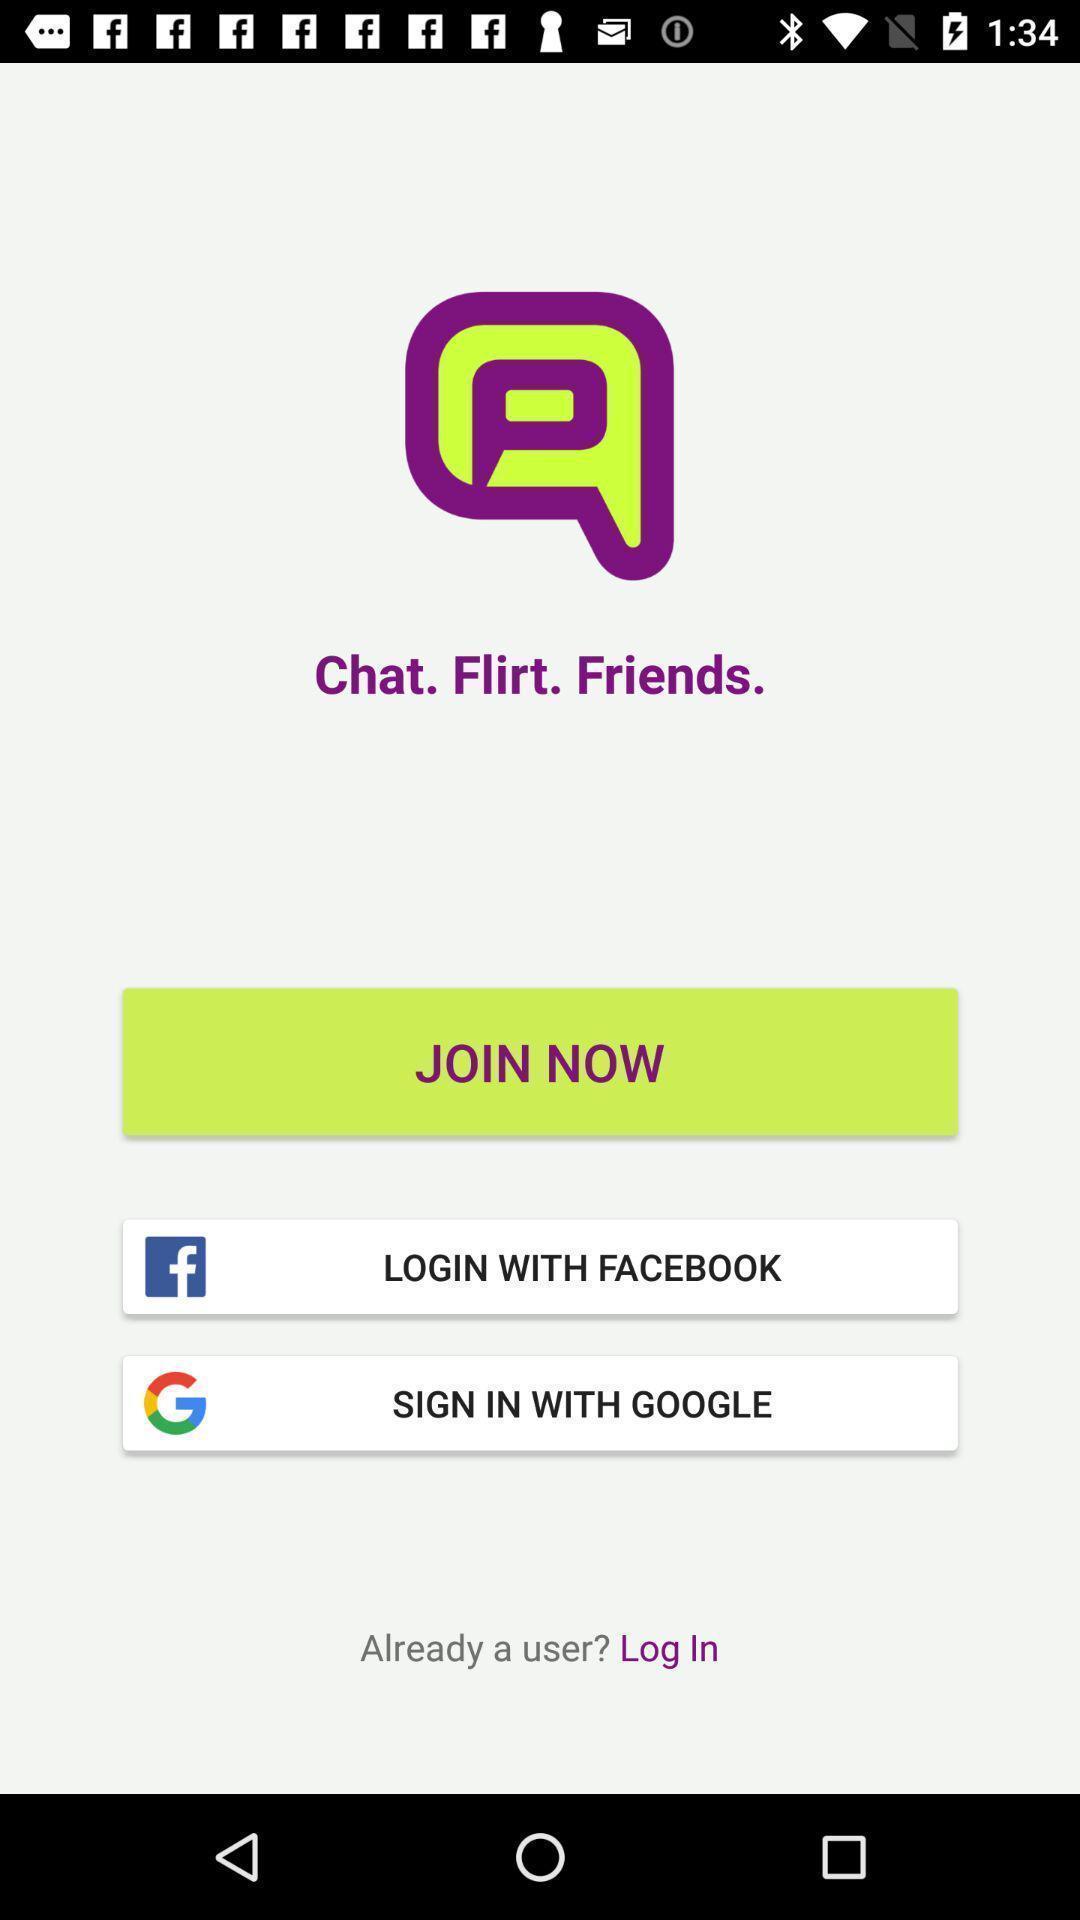Provide a description of this screenshot. Page displaying to login with social apps. 